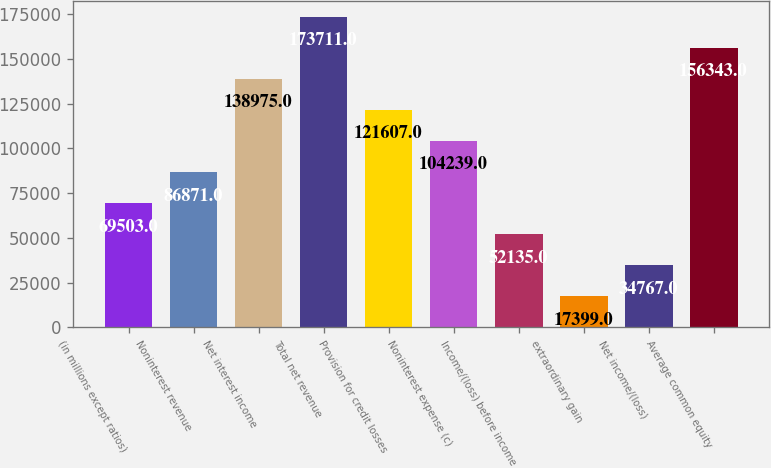Convert chart to OTSL. <chart><loc_0><loc_0><loc_500><loc_500><bar_chart><fcel>(in millions except ratios)<fcel>Noninterest revenue<fcel>Net interest income<fcel>Total net revenue<fcel>Provision for credit losses<fcel>Noninterest expense (c)<fcel>Income/(loss) before income<fcel>extraordinary gain<fcel>Net income/(loss)<fcel>Average common equity<nl><fcel>69503<fcel>86871<fcel>138975<fcel>173711<fcel>121607<fcel>104239<fcel>52135<fcel>17399<fcel>34767<fcel>156343<nl></chart> 